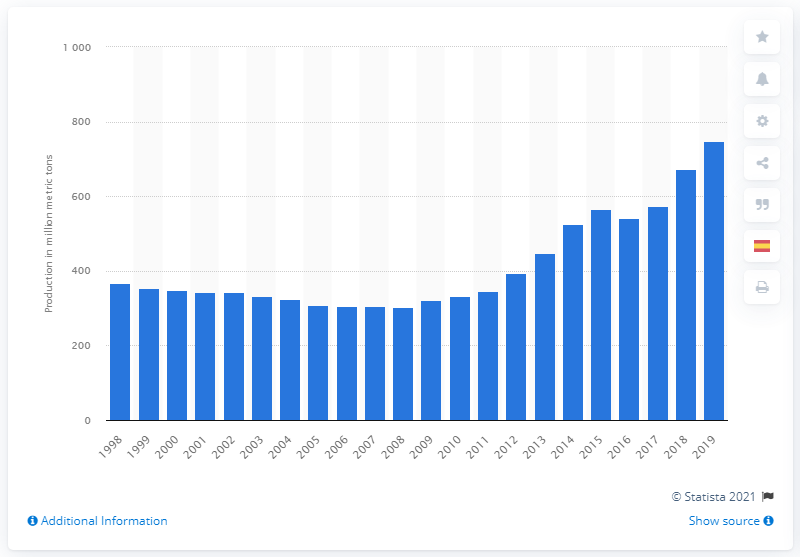Identify some key points in this picture. In 2019, the United States produced a total of 746.7 million barrels of oil. 